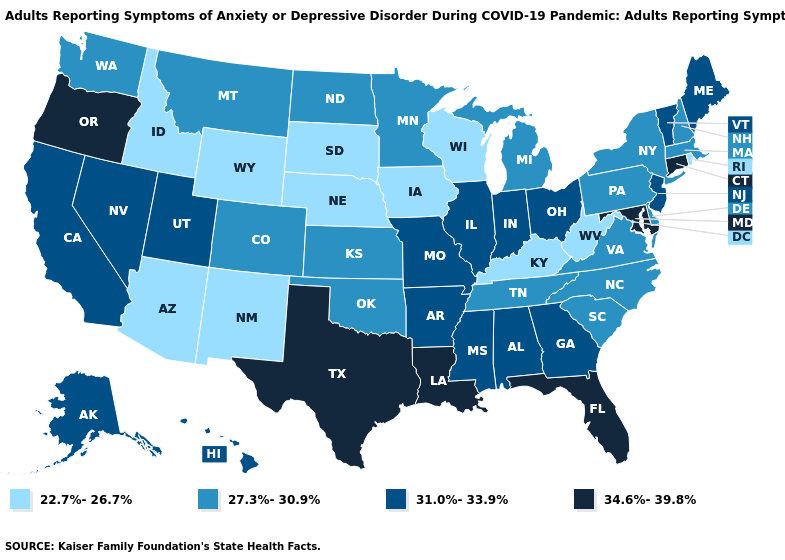Does Wyoming have the lowest value in the USA?
Keep it brief. Yes. What is the highest value in states that border Connecticut?
Quick response, please. 27.3%-30.9%. Name the states that have a value in the range 34.6%-39.8%?
Write a very short answer. Connecticut, Florida, Louisiana, Maryland, Oregon, Texas. What is the value of Louisiana?
Give a very brief answer. 34.6%-39.8%. Does Colorado have a higher value than Alaska?
Write a very short answer. No. Among the states that border Kentucky , which have the highest value?
Keep it brief. Illinois, Indiana, Missouri, Ohio. What is the value of Alabama?
Give a very brief answer. 31.0%-33.9%. Does Rhode Island have the lowest value in the Northeast?
Answer briefly. Yes. How many symbols are there in the legend?
Short answer required. 4. Name the states that have a value in the range 27.3%-30.9%?
Concise answer only. Colorado, Delaware, Kansas, Massachusetts, Michigan, Minnesota, Montana, New Hampshire, New York, North Carolina, North Dakota, Oklahoma, Pennsylvania, South Carolina, Tennessee, Virginia, Washington. What is the value of Arizona?
Concise answer only. 22.7%-26.7%. Which states have the highest value in the USA?
Be succinct. Connecticut, Florida, Louisiana, Maryland, Oregon, Texas. How many symbols are there in the legend?
Write a very short answer. 4. What is the value of West Virginia?
Concise answer only. 22.7%-26.7%. Does Utah have a lower value than Florida?
Be succinct. Yes. 